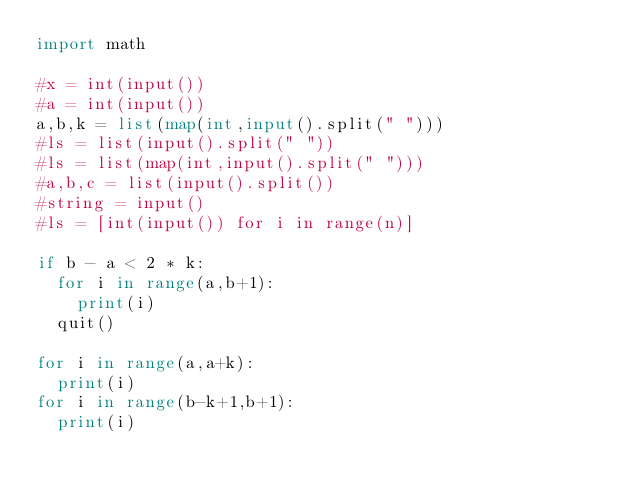Convert code to text. <code><loc_0><loc_0><loc_500><loc_500><_Python_>import math

#x = int(input())
#a = int(input())
a,b,k = list(map(int,input().split(" ")))
#ls = list(input().split(" "))
#ls = list(map(int,input().split(" ")))
#a,b,c = list(input().split())
#string = input()
#ls = [int(input()) for i in range(n)]

if b - a < 2 * k:
  for i in range(a,b+1):
    print(i)
  quit()

for i in range(a,a+k):
  print(i)
for i in range(b-k+1,b+1):
  print(i)</code> 